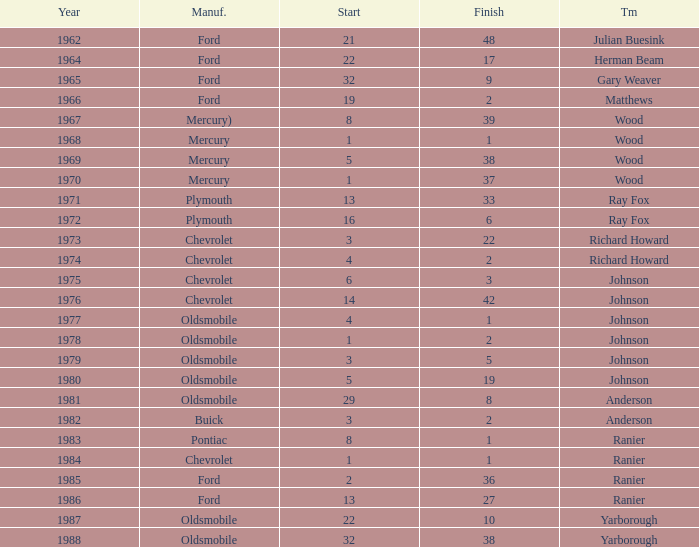Who was the maufacturer of the vehicle during the race where Cale Yarborough started at 19 and finished earlier than 42? Ford. 